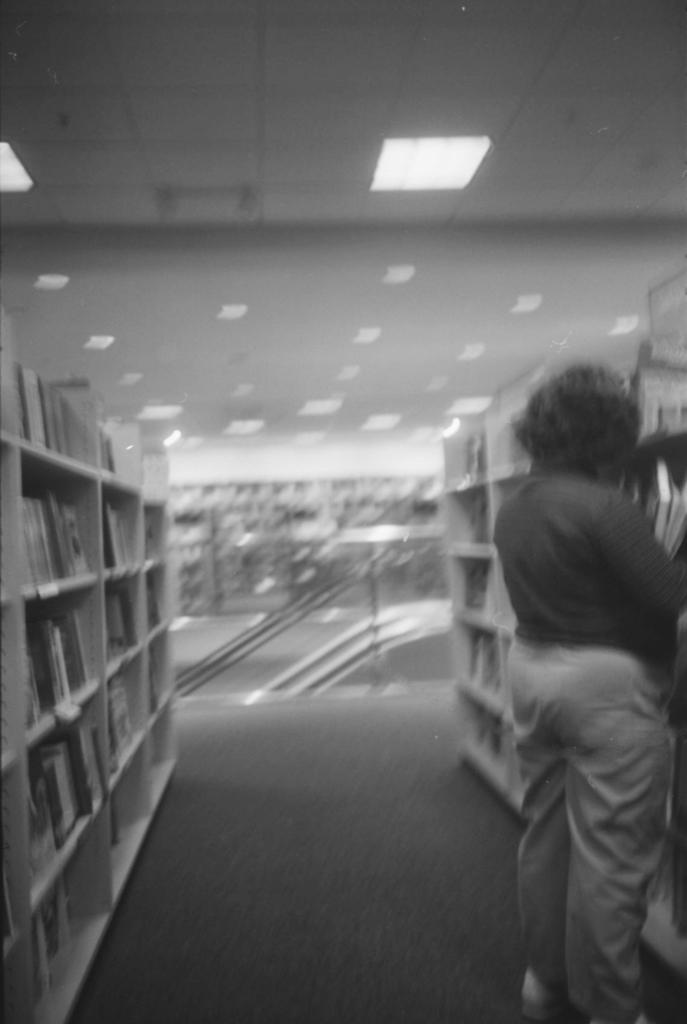Could you give a brief overview of what you see in this image? It is a black and white image and it is a inside picture of library. In this image person is standing in front of a bookshelf. At the top of the roof there are fall ceiling lights. 